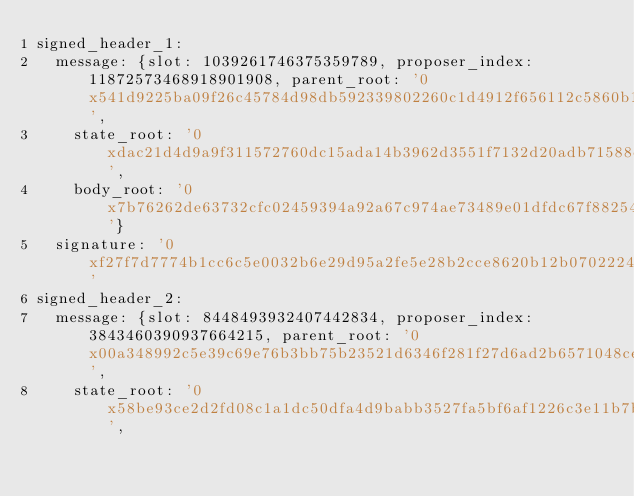<code> <loc_0><loc_0><loc_500><loc_500><_YAML_>signed_header_1:
  message: {slot: 1039261746375359789, proposer_index: 11872573468918901908, parent_root: '0x541d9225ba09f26c45784d98db592339802260c1d4912f656112c5860b16594b',
    state_root: '0xdac21d4d9a9f311572760dc15ada14b3962d3551f7132d20adb71588e0c4cda6',
    body_root: '0x7b76262de63732cfc02459394a92a67c974ae73489e01dfdc67f88254ea7bb16'}
  signature: '0xf27f7d7774b1cc6c5e0032b6e29d95a2fe5e28b2cce8620b12b070222486f748339f691deb9d79528ea27c89bd16d86848ce018ffa846a4db96498fc5f96f6fc204e02b208948820ccdb5479be120c53a9f109a937fd36df7adc124172bfd82f'
signed_header_2:
  message: {slot: 8448493932407442834, proposer_index: 3843460390937664215, parent_root: '0x00a348992c5e39c69e76b3bb75b23521d6346f281f27d6ad2b6571048ce7ab59',
    state_root: '0x58be93ce2d2fd08c1a1dc50dfa4d9babb3527fa5bf6af1226c3e11b7bcc29eba',</code> 